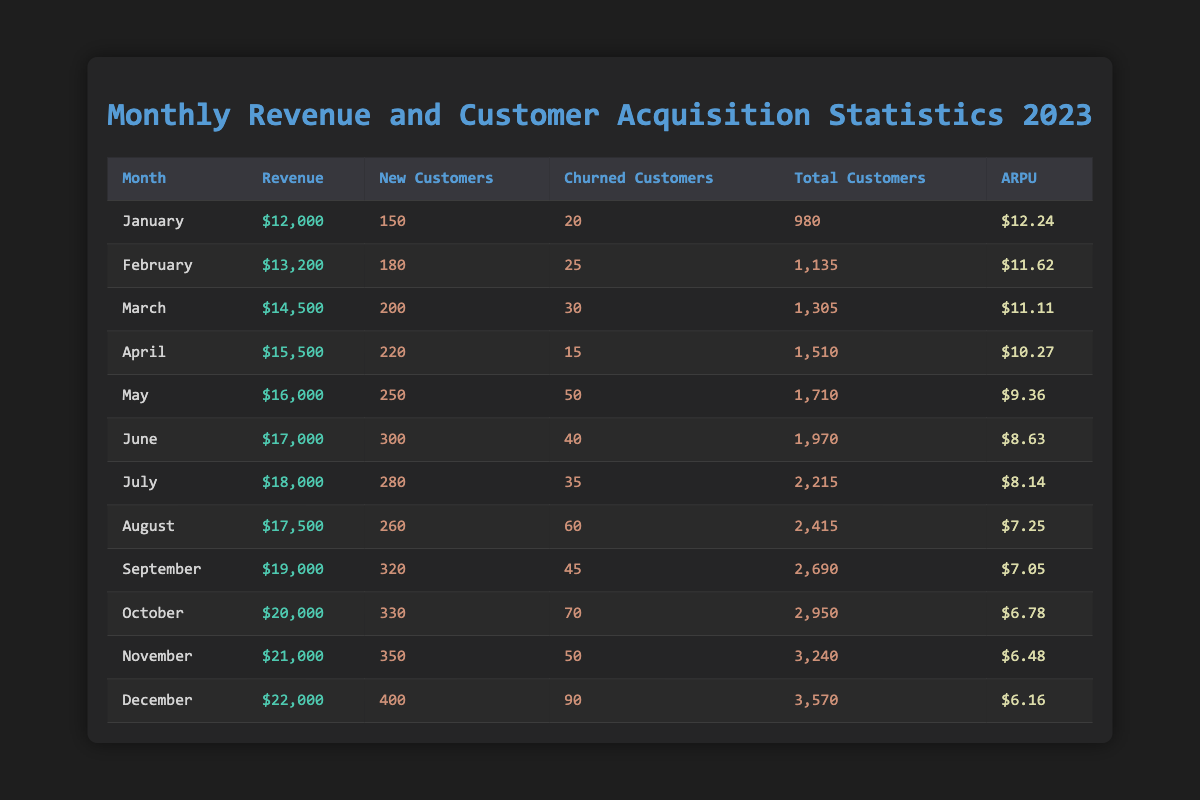What was the revenue in December? According to the table, the revenue for December is listed clearly as $22,000.
Answer: $22,000 How many new customers were acquired in June? The table specifies that in June, the number of new customers acquired was 300.
Answer: 300 What is the total revenue for the first half of the year (January to June)? To find the total revenue for the first half, sum up the revenues from January to June: $12,000 + $13,200 + $14,500 + $15,500 + $16,000 + $17,000 = $88,200.
Answer: $88,200 What was the average revenue per user (ARPU) in October? The average revenue per user for October is indicated in the table as $6.78.
Answer: $6.78 Did the number of churned customers increase or decrease from May to June? In May, there were 50 churned customers, and in June, it decreased to 40. Therefore, the number of churned customers decreased.
Answer: Decreased What is the total number of customers gained from January to March? The total customers gained can be calculated by summing the new customers for January (150), February (180), and March (200). Total = 150 + 180 + 200 = 530.
Answer: 530 What is the revenue trend observed from January to December? To determine the trend, observe the revenue values month by month. It starts at $12,000 in January and increases to $22,000 in December, indicating an upward trend throughout the year.
Answer: Upward trend How many churned customers were there in the month with the highest total customer count? The month with the highest total customer count is December, which has 3,570 total customers. In December, there were 90 churned customers.
Answer: 90 What was the highest average revenue per user throughout the year? Looking through the ARPU values, the highest one appears in January at $12.24.
Answer: $12.24 How much did the revenue increase from November to December? The revenue in November is $21,000 and in December it's $22,000, so the increase is $22,000 - $21,000 = $1,000.
Answer: $1,000 What is the difference in total customers between January and December? The total number of customers in January is 980, and in December it is 3,570. The difference is 3,570 - 980 = 2,590.
Answer: 2,590 Was there a month when new customer acquisition exceeded 300? Yes, in June, the new customers totaled 300, and it did not exceed that; however, in September, new customers were 320.
Answer: Yes 